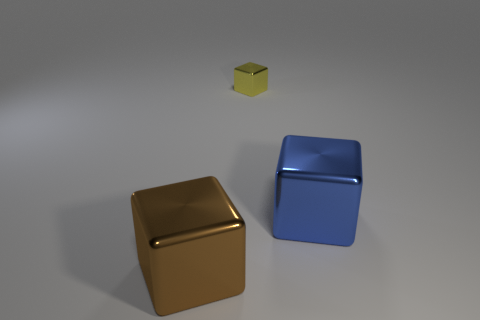Subtract all blue cubes. How many cubes are left? 2 Add 1 tiny yellow matte things. How many objects exist? 4 Subtract all blue blocks. How many blocks are left? 2 Subtract all brown balls. How many cyan blocks are left? 0 Subtract all big shiny things. Subtract all yellow things. How many objects are left? 0 Add 1 yellow shiny things. How many yellow shiny things are left? 2 Add 3 big metallic cubes. How many big metallic cubes exist? 5 Subtract 0 green spheres. How many objects are left? 3 Subtract all brown cubes. Subtract all gray spheres. How many cubes are left? 2 